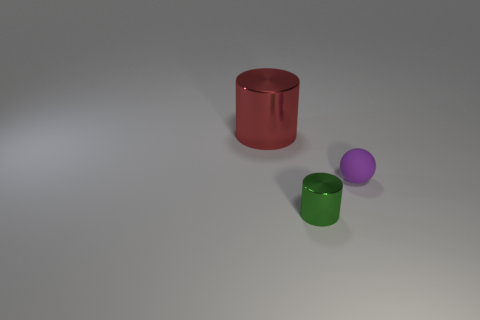Add 1 rubber things. How many objects exist? 4 Subtract all cylinders. How many objects are left? 1 Subtract all yellow cylinders. Subtract all matte spheres. How many objects are left? 2 Add 3 red metal objects. How many red metal objects are left? 4 Add 1 purple matte balls. How many purple matte balls exist? 2 Subtract 0 green balls. How many objects are left? 3 